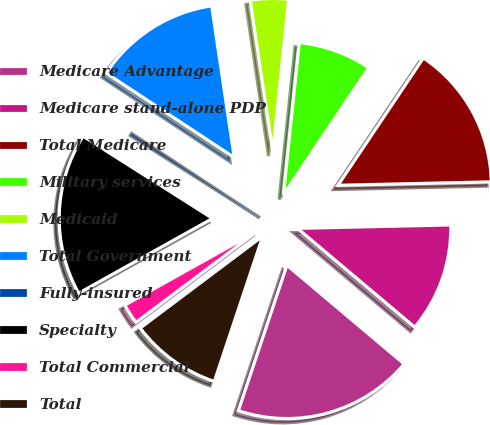<chart> <loc_0><loc_0><loc_500><loc_500><pie_chart><fcel>Medicare Advantage<fcel>Medicare stand-alone PDP<fcel>Total Medicare<fcel>Military services<fcel>Medicaid<fcel>Total Government<fcel>Fully-insured<fcel>Specialty<fcel>Total Commercial<fcel>Total<nl><fcel>18.98%<fcel>11.5%<fcel>15.24%<fcel>7.75%<fcel>4.01%<fcel>13.37%<fcel>0.27%<fcel>17.11%<fcel>2.14%<fcel>9.63%<nl></chart> 